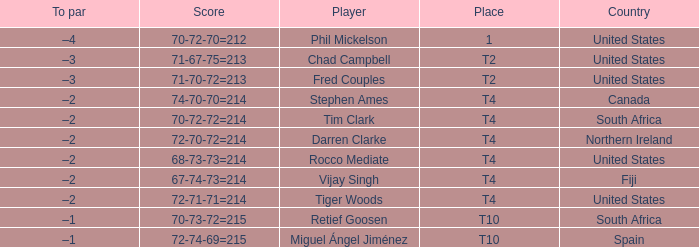What country does Rocco Mediate play for? United States. 